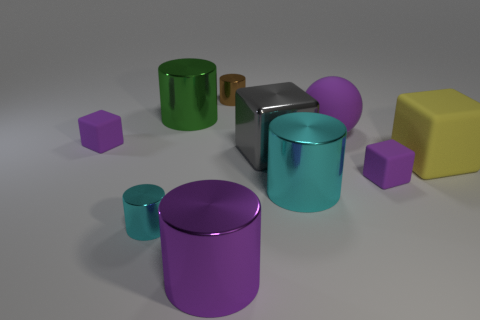What color is the large ball?
Keep it short and to the point. Purple. Is the number of tiny cyan cylinders greater than the number of small cubes?
Your answer should be very brief. No. How many objects are purple rubber objects on the right side of the purple sphere or large metallic cylinders?
Offer a very short reply. 4. Does the ball have the same material as the brown object?
Your answer should be very brief. No. There is another cyan shiny thing that is the same shape as the small cyan shiny object; what is its size?
Ensure brevity in your answer.  Large. There is a purple matte thing that is to the left of the large purple metallic thing; is it the same shape as the cyan shiny object right of the large green metallic thing?
Give a very brief answer. No. There is a yellow rubber thing; is it the same size as the cyan shiny thing that is on the right side of the big gray shiny block?
Provide a short and direct response. Yes. How many other objects are there of the same material as the big sphere?
Offer a terse response. 3. Is there any other thing that has the same shape as the small brown object?
Give a very brief answer. Yes. There is a rubber cube that is to the right of the tiny purple matte thing to the right of the big sphere that is in front of the large green shiny object; what color is it?
Give a very brief answer. Yellow. 